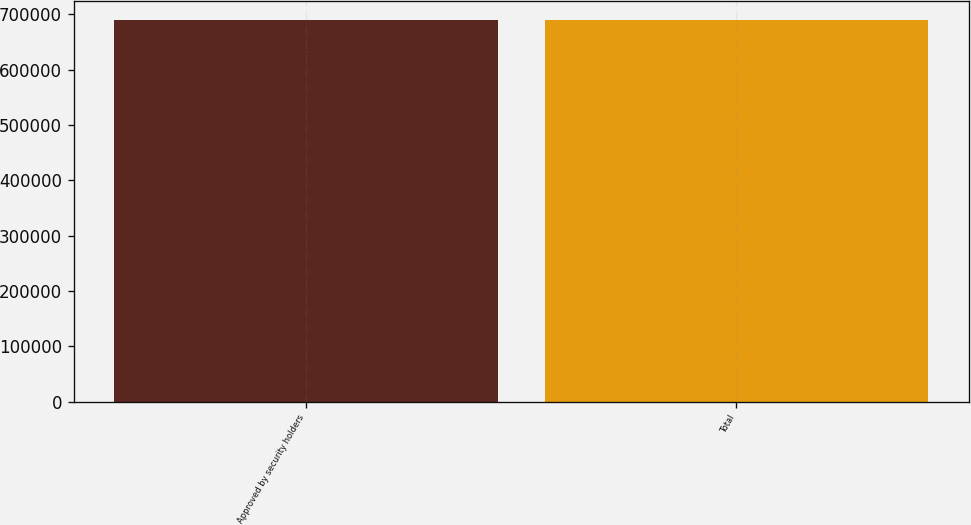<chart> <loc_0><loc_0><loc_500><loc_500><bar_chart><fcel>Approved by security holders<fcel>Total<nl><fcel>689356<fcel>689356<nl></chart> 